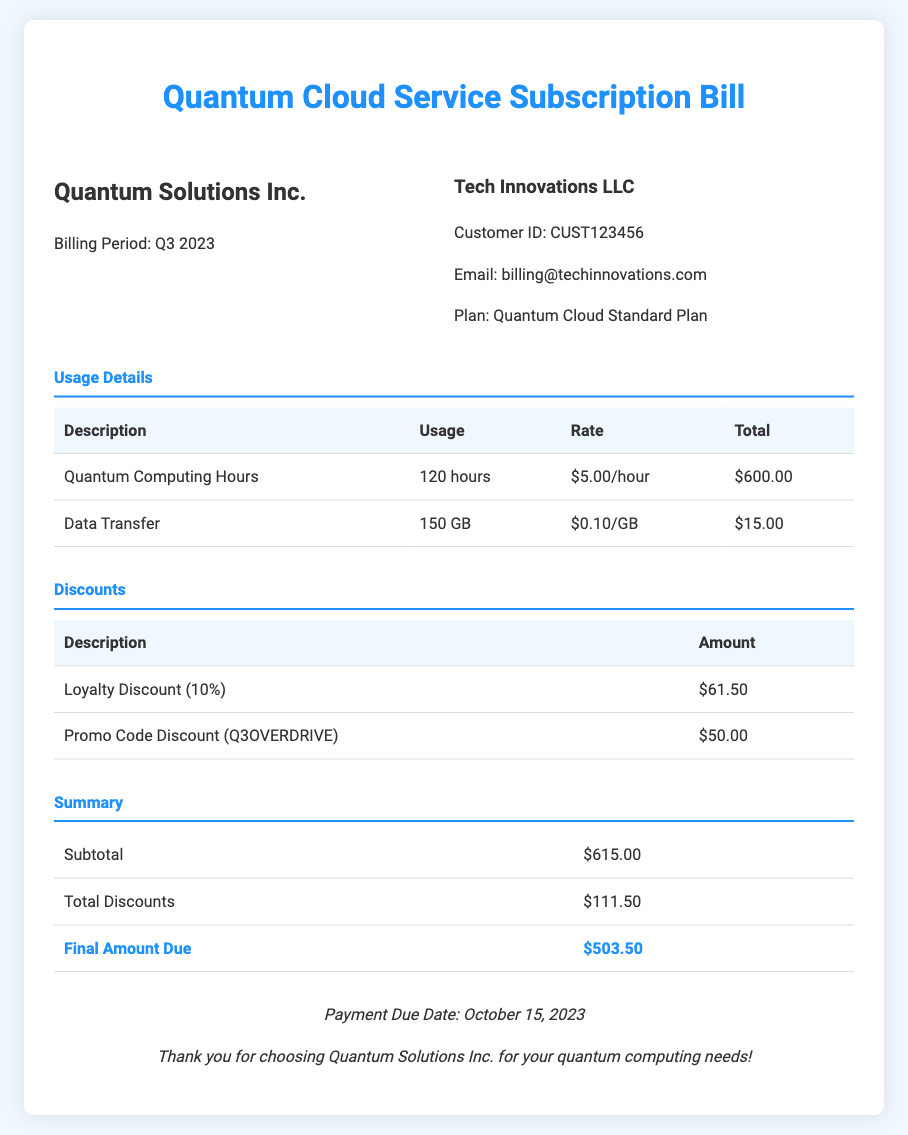What is the billing period? The billing period for this document is explicitly stated as Q3 2023.
Answer: Q3 2023 How many quantum computing hours were used? The bill lists 120 hours as the total quantum computing hours used during the billing period.
Answer: 120 hours What was the total cost for data transfer? The document indicates that the total cost for data transfer of 150 GB is $15.00.
Answer: $15.00 What is the loyalty discount percentage? The loyalty discount is listed as 10% in the discounts section of the bill.
Answer: 10% What is the final amount due? The final amount due is calculated and presented in the summary section as $503.50.
Answer: $503.50 What was the total amount of discounts applied? The total amount of discounts applied, shown in the summary, is $111.50.
Answer: $111.50 Who is the customer? The customer is identified as Tech Innovations LLC in the customer info section.
Answer: Tech Innovations LLC When is the payment due date? The due date for payment is mentioned at the bottom of the document as October 15, 2023.
Answer: October 15, 2023 What plan is subscribed to? The document specifies that the subscription plan is the Quantum Cloud Standard Plan.
Answer: Quantum Cloud Standard Plan 